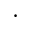<formula> <loc_0><loc_0><loc_500><loc_500>\cdot</formula> 